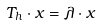<formula> <loc_0><loc_0><loc_500><loc_500>T _ { h } \cdot x = \lambda \cdot x</formula> 